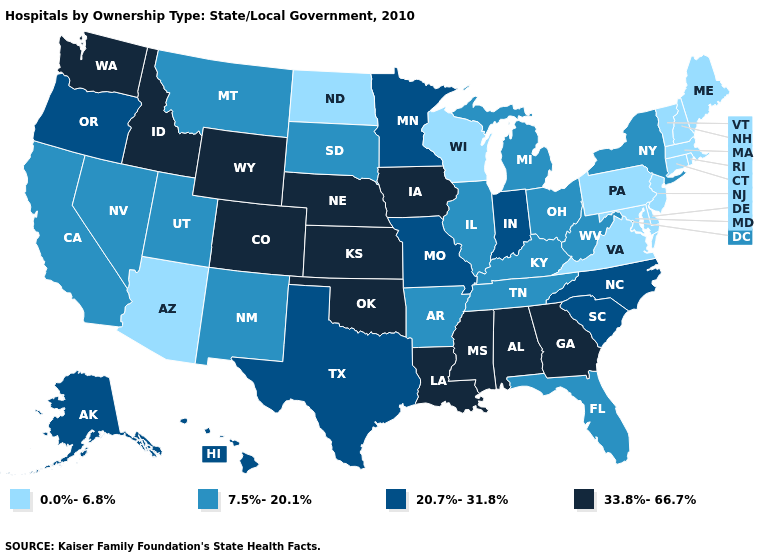Name the states that have a value in the range 0.0%-6.8%?
Write a very short answer. Arizona, Connecticut, Delaware, Maine, Maryland, Massachusetts, New Hampshire, New Jersey, North Dakota, Pennsylvania, Rhode Island, Vermont, Virginia, Wisconsin. What is the value of Georgia?
Short answer required. 33.8%-66.7%. What is the value of Kansas?
Short answer required. 33.8%-66.7%. Which states have the highest value in the USA?
Write a very short answer. Alabama, Colorado, Georgia, Idaho, Iowa, Kansas, Louisiana, Mississippi, Nebraska, Oklahoma, Washington, Wyoming. What is the highest value in the USA?
Short answer required. 33.8%-66.7%. Which states have the lowest value in the USA?
Quick response, please. Arizona, Connecticut, Delaware, Maine, Maryland, Massachusetts, New Hampshire, New Jersey, North Dakota, Pennsylvania, Rhode Island, Vermont, Virginia, Wisconsin. Which states hav the highest value in the West?
Be succinct. Colorado, Idaho, Washington, Wyoming. Name the states that have a value in the range 20.7%-31.8%?
Concise answer only. Alaska, Hawaii, Indiana, Minnesota, Missouri, North Carolina, Oregon, South Carolina, Texas. Does the first symbol in the legend represent the smallest category?
Quick response, please. Yes. What is the value of Minnesota?
Quick response, please. 20.7%-31.8%. Name the states that have a value in the range 7.5%-20.1%?
Keep it brief. Arkansas, California, Florida, Illinois, Kentucky, Michigan, Montana, Nevada, New Mexico, New York, Ohio, South Dakota, Tennessee, Utah, West Virginia. What is the value of Washington?
Concise answer only. 33.8%-66.7%. What is the value of Oregon?
Concise answer only. 20.7%-31.8%. What is the value of Maryland?
Concise answer only. 0.0%-6.8%. 